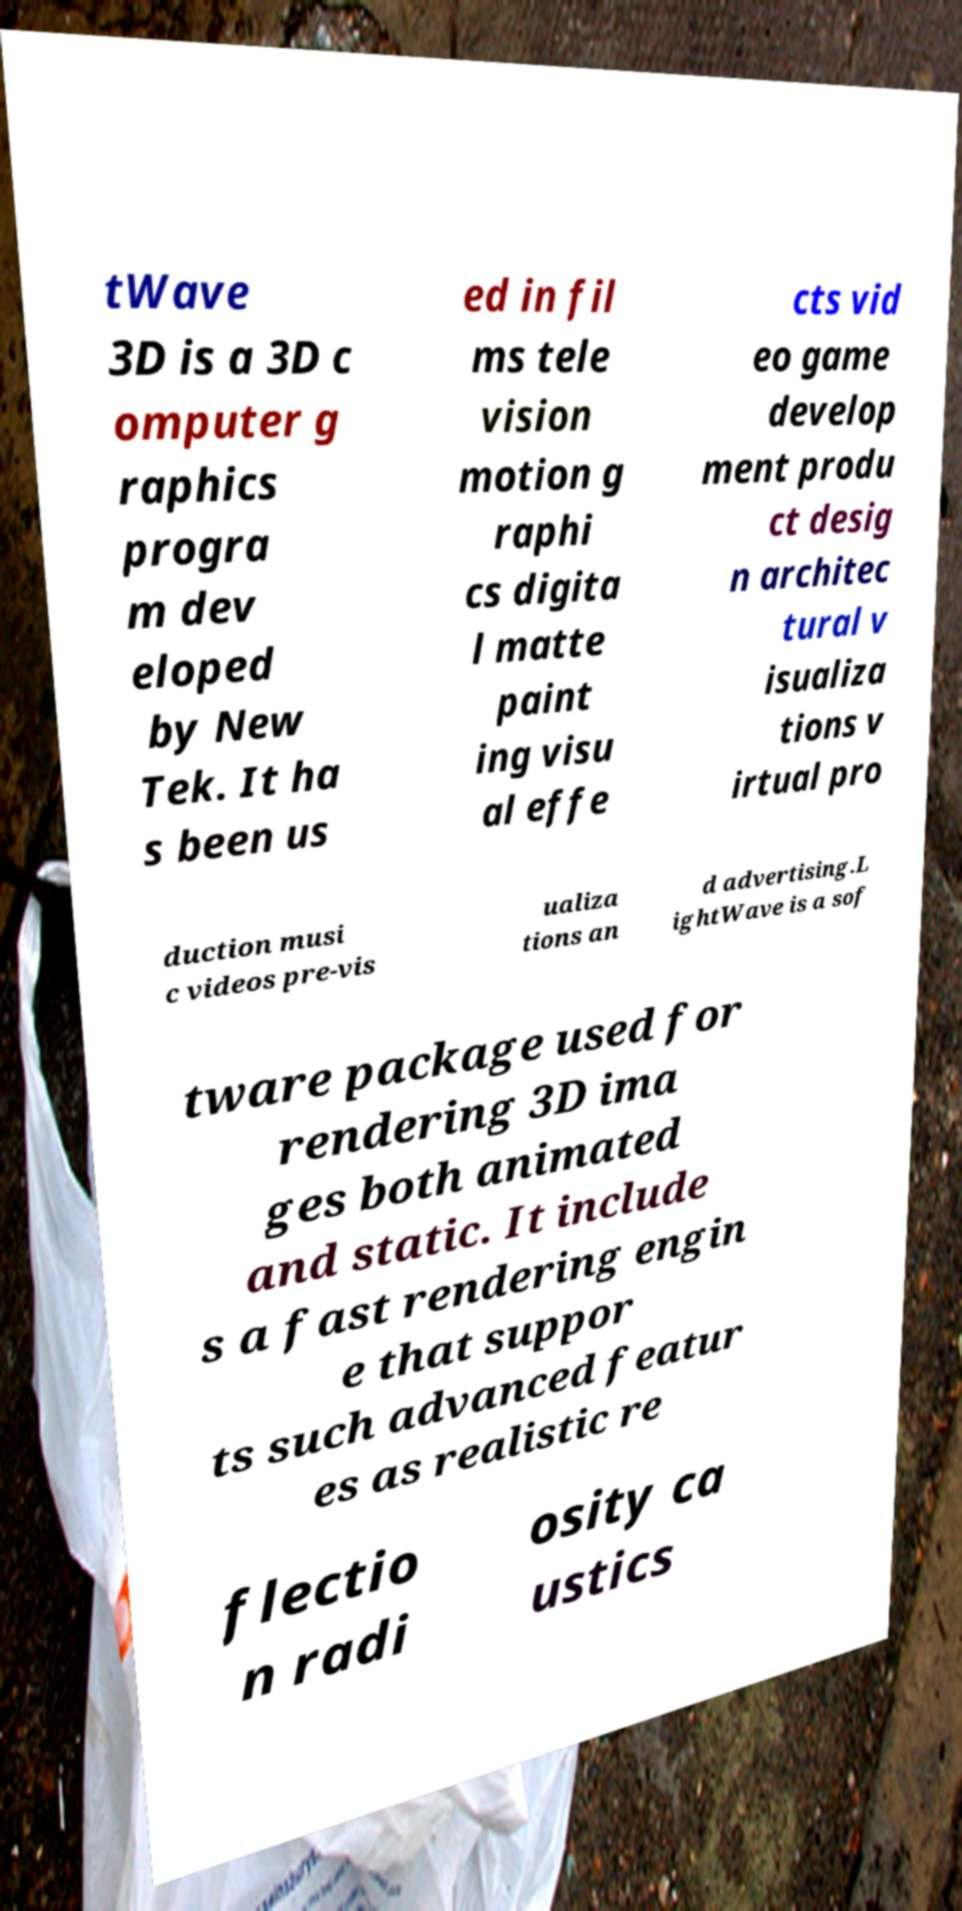What messages or text are displayed in this image? I need them in a readable, typed format. tWave 3D is a 3D c omputer g raphics progra m dev eloped by New Tek. It ha s been us ed in fil ms tele vision motion g raphi cs digita l matte paint ing visu al effe cts vid eo game develop ment produ ct desig n architec tural v isualiza tions v irtual pro duction musi c videos pre-vis ualiza tions an d advertising.L ightWave is a sof tware package used for rendering 3D ima ges both animated and static. It include s a fast rendering engin e that suppor ts such advanced featur es as realistic re flectio n radi osity ca ustics 